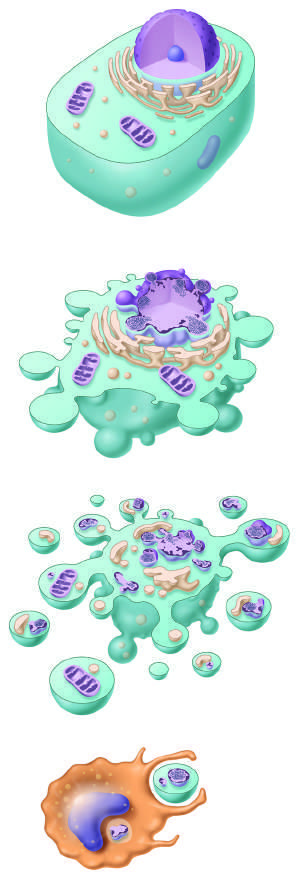re the cellular alterations in apoptosis illustrated?
Answer the question using a single word or phrase. Yes 